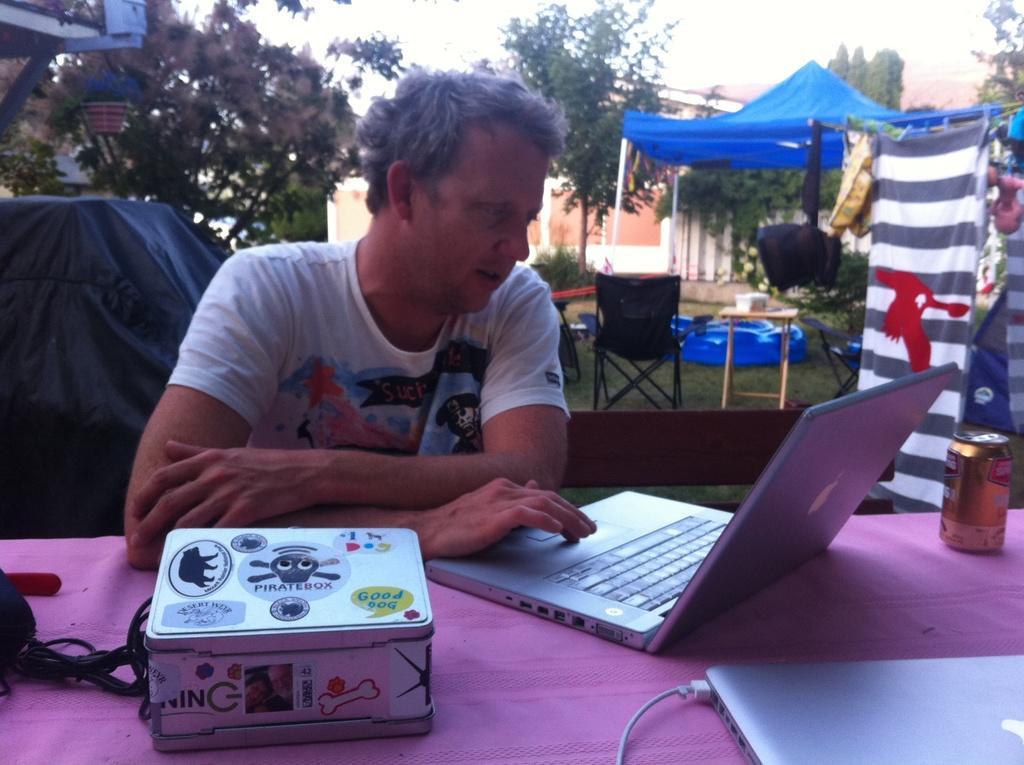Could you give a brief overview of what you see in this image? In this image i can see a person sitting in front of a table, and on the table i can see 2 laptops, a tin and a box. In the background i can see a tent, few clothes, a chair, trees and the sky. 